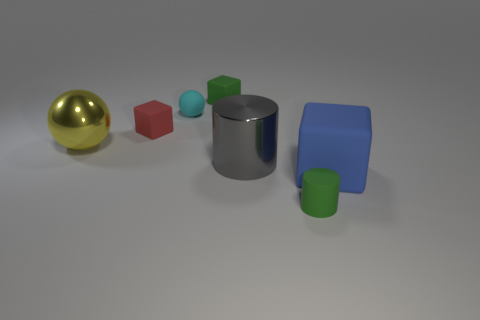What number of cylinders are large shiny objects or tiny green rubber things?
Offer a terse response. 2. There is a small thing that is both to the right of the small matte ball and behind the tiny green rubber cylinder; what is its shape?
Offer a terse response. Cube. Are there the same number of big matte objects behind the tiny green cube and rubber cylinders that are behind the blue thing?
Make the answer very short. Yes. How many objects are tiny cyan matte spheres or matte cylinders?
Keep it short and to the point. 2. What is the color of the other matte object that is the same size as the yellow object?
Your answer should be very brief. Blue. How many objects are things that are in front of the tiny cyan sphere or tiny objects that are to the right of the tiny cyan matte thing?
Ensure brevity in your answer.  6. Are there an equal number of tiny objects behind the yellow shiny sphere and yellow metal objects?
Keep it short and to the point. No. There is a gray cylinder in front of the red object; is its size the same as the ball that is behind the big ball?
Your answer should be very brief. No. What number of other objects are the same size as the gray object?
Provide a short and direct response. 2. Are there any small blocks on the left side of the metal thing left of the green thing that is behind the cyan object?
Give a very brief answer. No. 